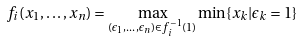Convert formula to latex. <formula><loc_0><loc_0><loc_500><loc_500>f _ { i } ( x _ { 1 } , \dots , x _ { n } ) = \max _ { ( \epsilon _ { 1 } , \dots , \epsilon _ { n } ) \in f _ { i } ^ { - 1 } ( 1 ) } \min \{ x _ { k } | \epsilon _ { k } = 1 \}</formula> 